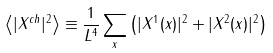Convert formula to latex. <formula><loc_0><loc_0><loc_500><loc_500>\left < | X ^ { c h } | ^ { 2 } \right > \equiv \frac { 1 } { L ^ { 4 } } \sum _ { x } \left ( | X ^ { 1 } ( x ) | ^ { 2 } + | X ^ { 2 } ( x ) | ^ { 2 } \right )</formula> 